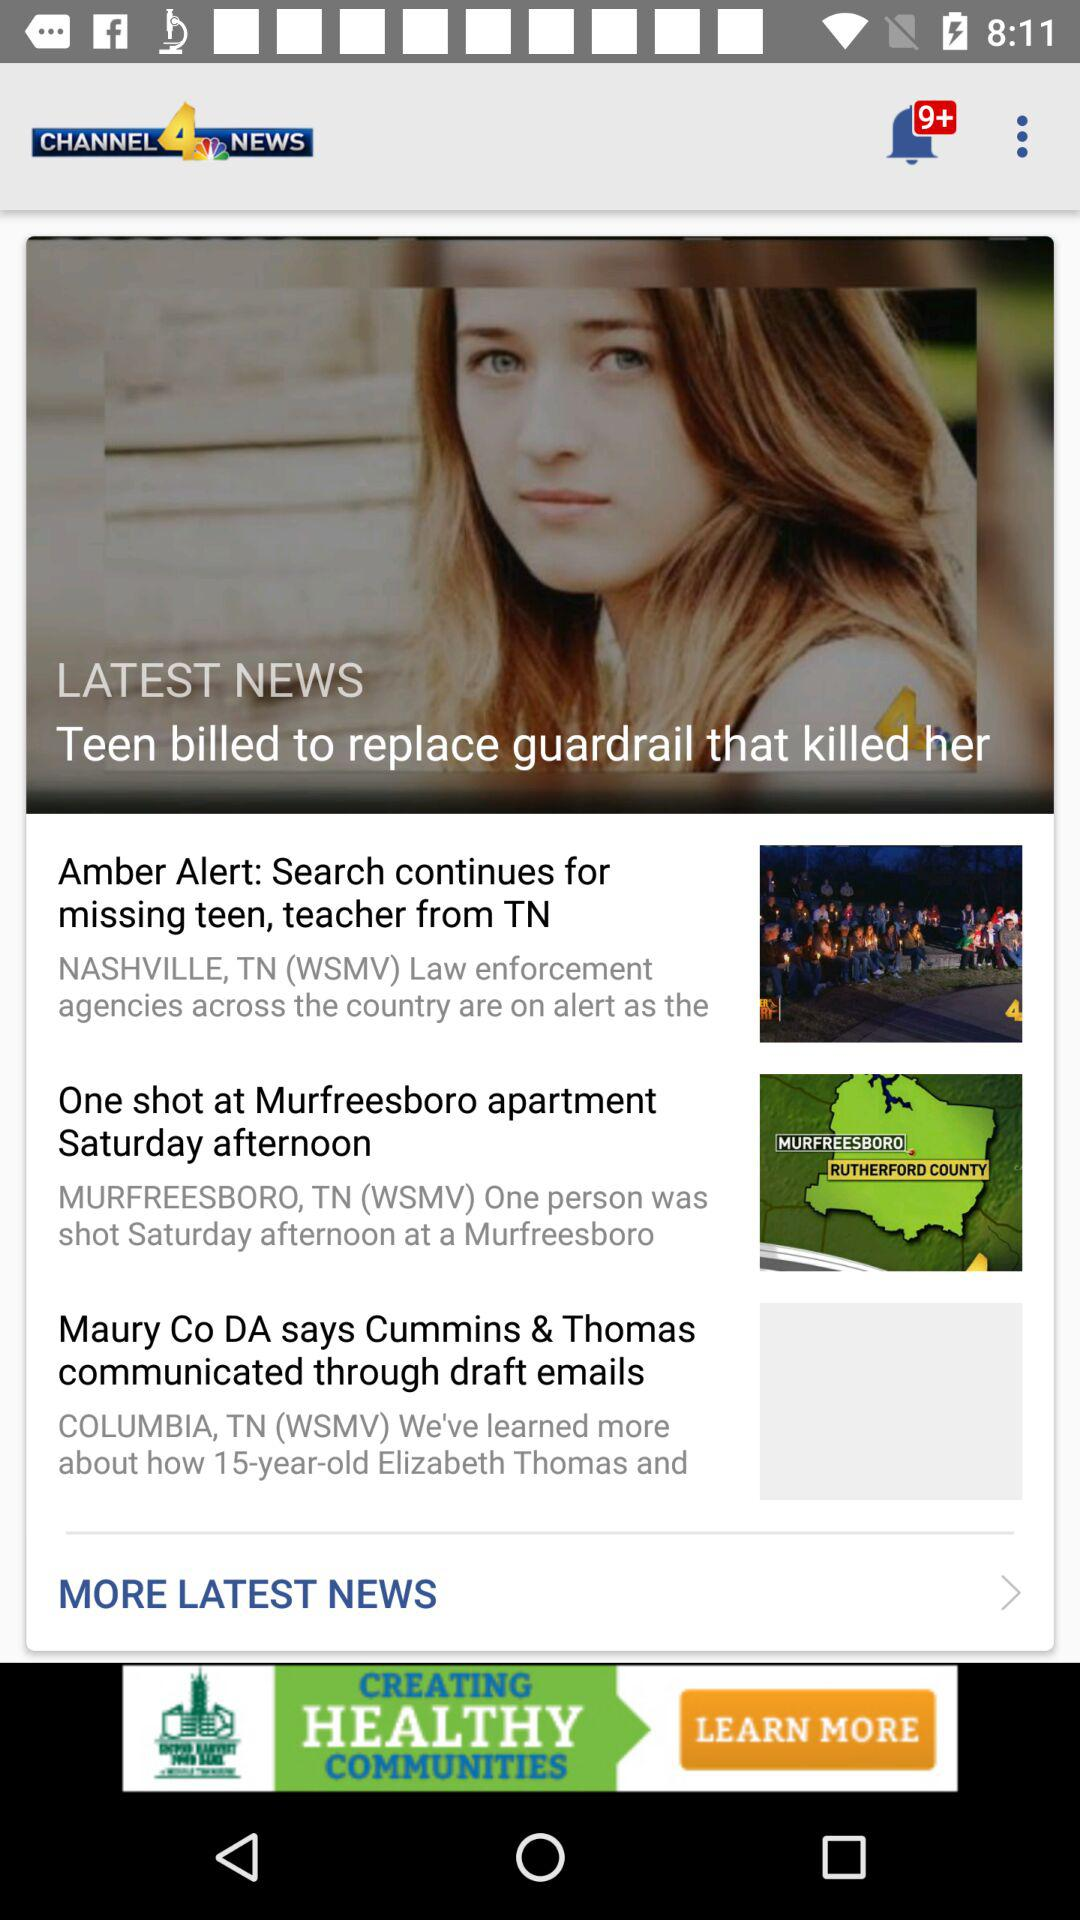How many unread notifications are there? There are more than 9 unread notifications. 